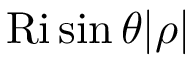<formula> <loc_0><loc_0><loc_500><loc_500>R i \sin \theta | \rho |</formula> 